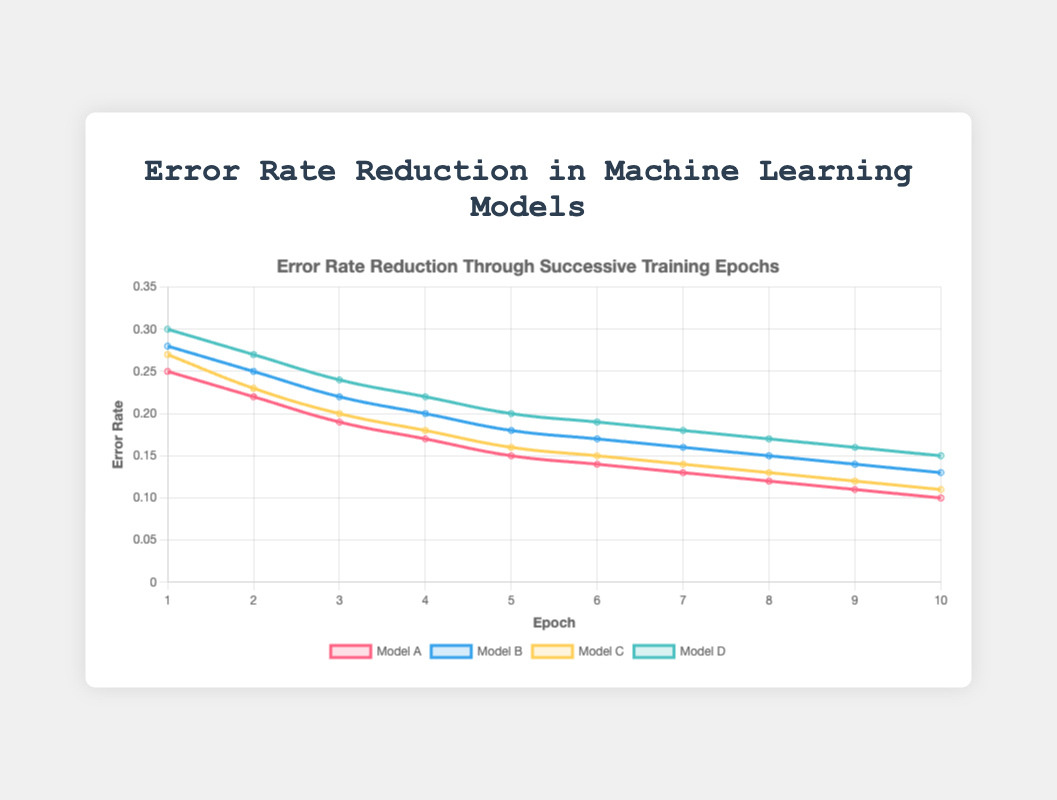Which model has the lowest error rate at epoch 10? By looking at the data points at epoch 10 for each model, Model A has an error rate of 0.10, Model B has 0.13, Model C has 0.11, and Model D has 0.15. The lowest value among these is 0.10 for Model A.
Answer: Model A What is the average error rate of Model C over all epochs? Sum the error rates of Model C across all epochs: 0.27 + 0.23 + 0.20 + 0.18 + 0.16 + 0.15 + 0.14 + 0.13 + 0.12 + 0.11 = 1.69, and then divide by the number of epochs: 1.69 / 10 = 0.169
Answer: 0.169 Which model shows the most consistent error rate reduction, and how do you determine this? Calculate the error rate reduction for each successive epoch for each model and compare the variability. For Model A: 0.25 - 0.22, 0.22 - 0.19, 0.19 - 0.17, 0.17 - 0.15, etc. After calculating reductions for each model, check which set of differences is most consistent (smallest range). Model A shows consistent reductions of approximately 0.02-0.03 per epoch. This consistency can be visually confirmed by the smoother decline in the plot.
Answer: Model A At which epoch does Model D's error rate coincide with the current error rate of Model A? Check the data points where Model D's error rate first matches Model A's current error rate. At epoch 8, Model D's error rate is 0.17, which is the error rate Model A had between epochs 3 (0.19) and 4 (0.17)
Answer: Epoch 8 How much total reduction in error rate does Model B achieve by epoch 10? Calculate the difference between the initial error rate and the error rate at epoch 10 for Model B: 0.28 - 0.13 = 0.15
Answer: 0.15 By epoch 6, which model reduced the most error in comparison to its own starting error rate? Compute the error reduction by epoch 6 for all models: 
- Model A: 0.25 - 0.14 = 0.11
- Model B: 0.28 - 0.17 = 0.11
- Model C: 0.27 - 0.15 = 0.12
- Model D: 0.30 - 0.19 = 0.11
Model C has the highest reduction of 0.12.
Answer: Model C Which epoch shows the greatest common consistent trend in error rate reduction across all models? Each epoch should be checked for consistent drops across all models. The epochs consistently show a reduction but since the magnitude of reduction per epoch generally decreases, the greatest reductions are typically early. Looking at the data, the most consistent significant reduction is between epoch 1 to epoch 2.
Answer: Epoch 1 to 2 What difference can you observe in error rates between Models B and D at epoch 5? Check the error rates for Models B and D at epoch 5. Model B has an error rate of 0.18, and Model D has an error rate of 0.20. The difference is 0.20 - 0.18 = 0.02.
Answer: 0.02 Comparing Models B and C, which one has a steeper decline in error rate by epoch 4, and by how much? Calculate the decline for both models from epoch 1 to epoch 4:
- Model B: 0.28 - 0.20 = 0.08
- Model C: 0.27 - 0.18 = 0.09
Model C has a steeper decline by 0.01.
Answer: Model C by 0.01 Which model had the smallest reduction in error rate between epoch 8 and epoch 10? Calculate the reduction between epoch 8 and epoch 10 for each model:
- Model A: 0.12 - 0.10 = 0.02
- Model B: 0.15 - 0.13 = 0.02
- Model C: 0.13 - 0.11 = 0.02
- Model D: 0.17 - 0.15 = 0.02
All models had the same reduction in this period.
Answer: All models equal 